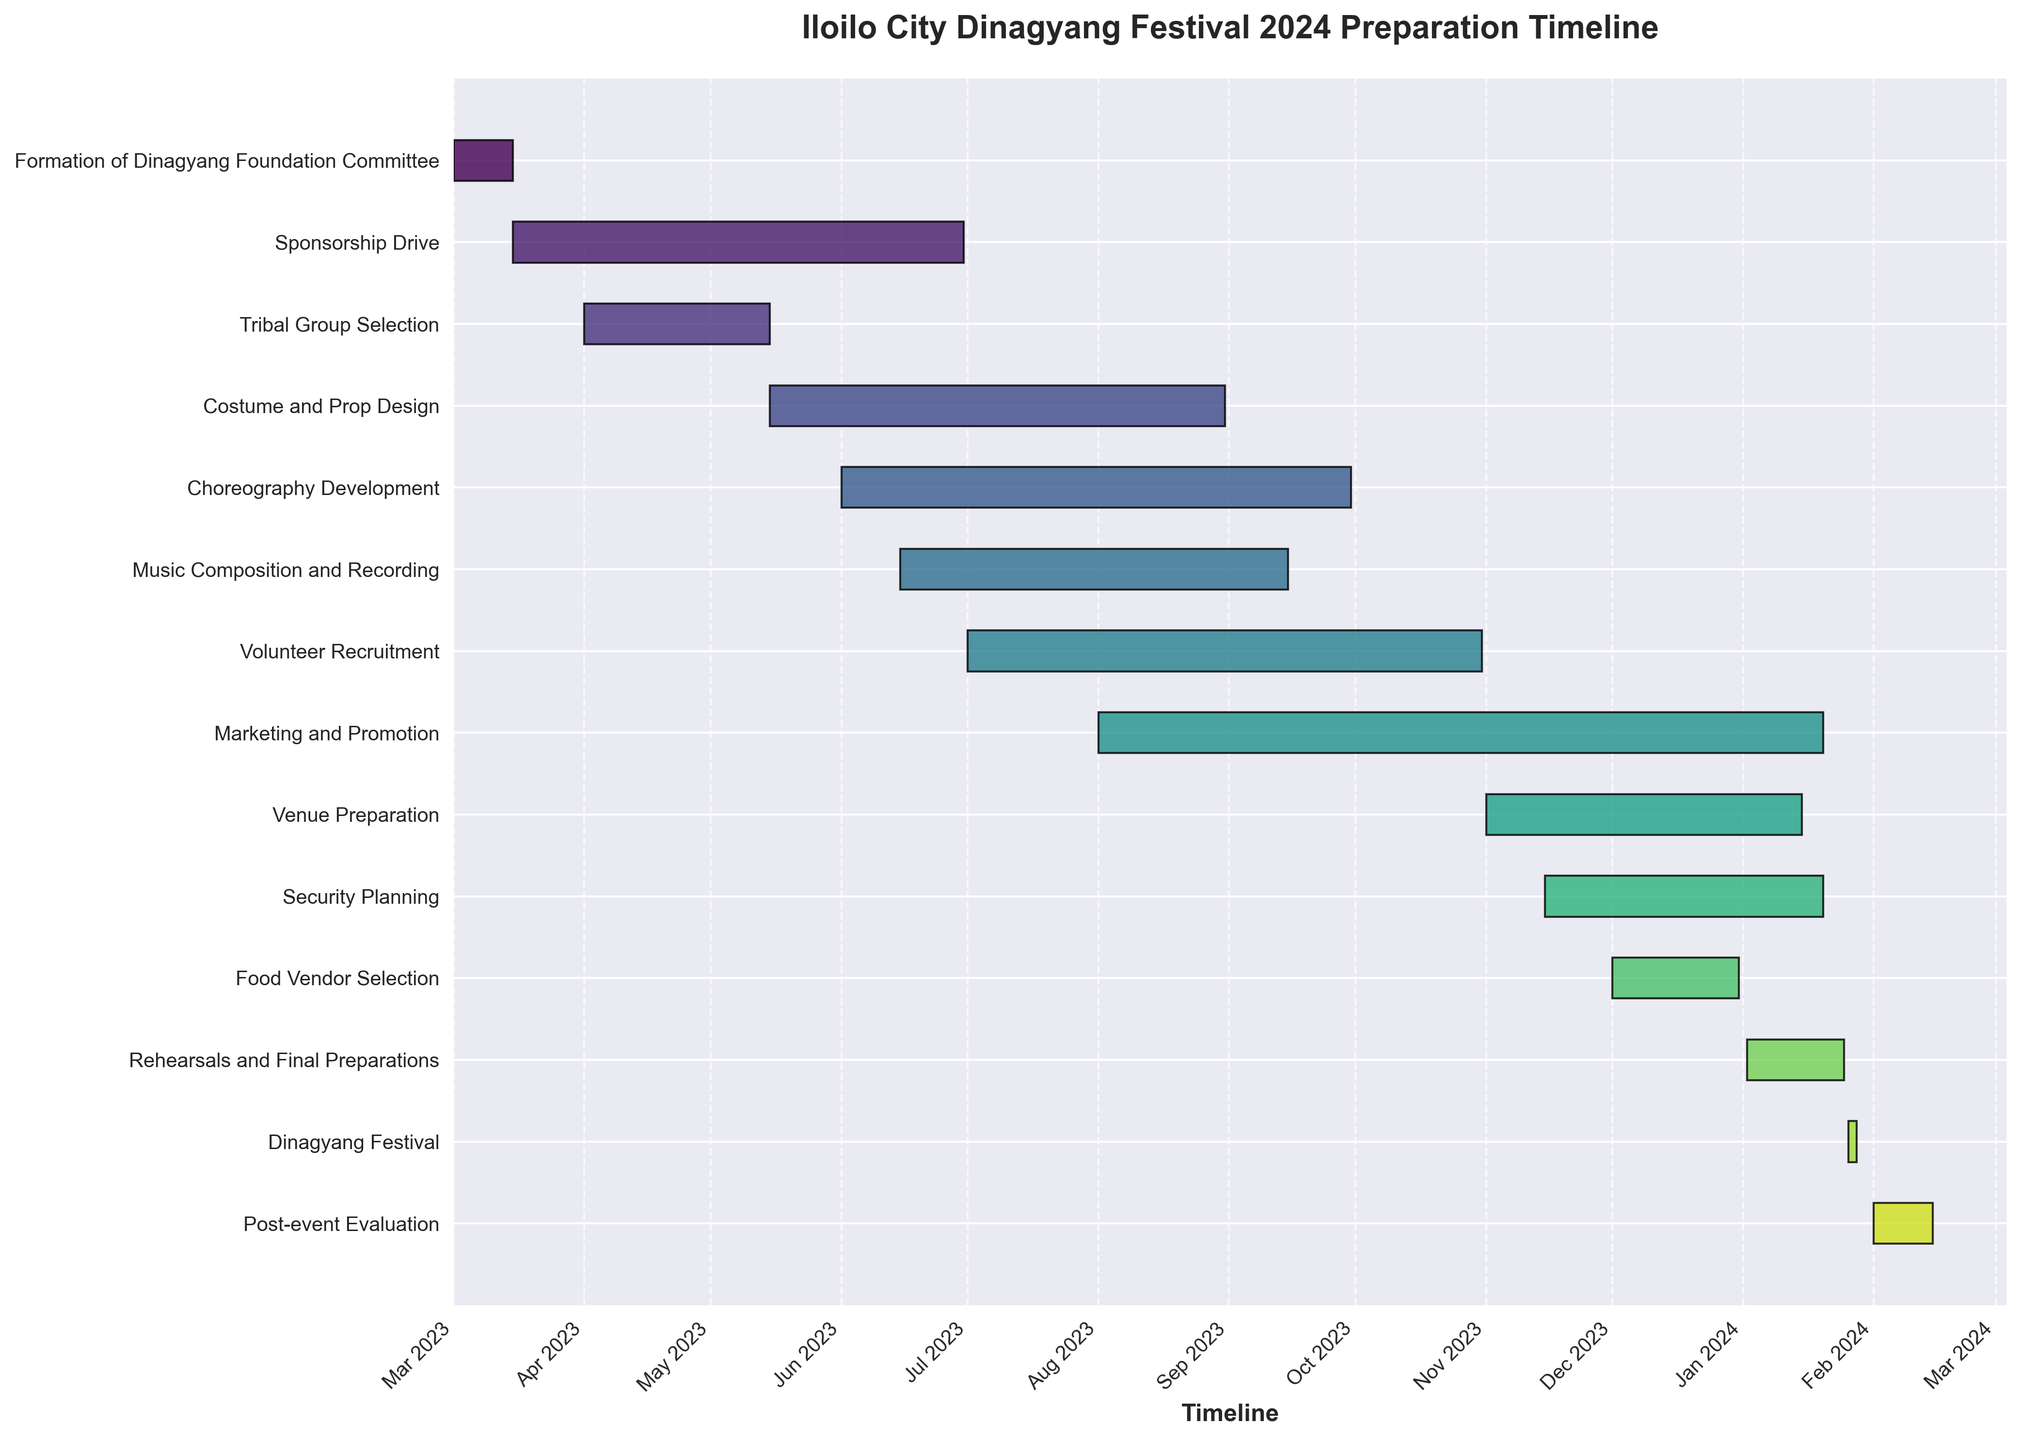When does the Dinagyang Festival take place? The title mentions "Iloilo City Dinagyang Festival 2024 Preparation Timeline," and the specific task "Dinagyang Festival" shows dates. Locate the task "Dinagyang Festival," which spans from January 26 to January 28, 2024.
Answer: January 26-28, 2024 Which task has the longest duration? Check and compare each task's duration by calculating the difference between the "Start Date" and "End Date." "Marketing and Promotion" spans from August 1, 2023, to January 20, 2024, giving it the longest duration.
Answer: Marketing and Promotion Are "Volunteer Recruitment" and "Marketing and Promotion" overlapping? Examine the "Start Date" and "End Date" of the two tasks. "Volunteer Recruitment" starts on July 1, 2023, and ends on October 31, 2023. "Marketing and Promotion" starts on August 1, 2023, and ends on January 20, 2024. They overlap from August 1, 2023, to October 31, 2023.
Answer: Yes Which tasks are involved in preparation simultaneously in November 2023? Identify all tasks occurring in November 2023 by comparing start and end dates. "Volunteer Recruitment," "Marketing and Promotion," "Venue Preparation," "Security Planning," and "Food Vendor Selection" are running in November 2023.
Answer: Volunteer Recruitment, Marketing and Promotion, Venue Preparation, Security Planning, Food Vendor Selection Which task ends immediately before "Rehearsals and Final Preparations"? "Rehearsals and Final Preparations" starts on January 2, 2024. Check tasks ending before this date. "Food Vendor Selection" ends on December 31, 2023.
Answer: Food Vendor Selection How long does it take to develop the choreography? Find the duration of "Choreography Development" by subtracting its "Start Date" (June 1, 2023) from its "End Date" (September 30, 2023). The duration is 122 days.
Answer: 122 days What is the timeline for "Security Planning"? Locate the start and end dates for "Security Planning," which are November 15, 2023, to January 20, 2024.
Answer: November 15, 2023, to January 20, 2024 Which starts first: "Costume and Prop Design" or "Music Composition and Recording"? Compare the start dates of the two tasks. "Costume and Prop Design" starts on May 15, 2023, and "Music Composition and Recording" starts on June 15, 2023. The "Costume and Prop Design" starts earlier.
Answer: Costume and Prop Design How many tasks need to be completed before the actual festival starts? Count the number of tasks with end dates before January 26, 2024 (the start of the festival). The tasks are 12 out of the total 13 (excluding the festival itself).
Answer: 12 tasks 